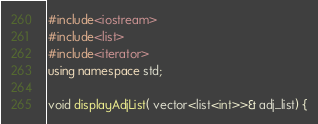Convert code to text. <code><loc_0><loc_0><loc_500><loc_500><_C++_>#include<iostream>
#include<list>
#include<iterator>
using namespace std;

void displayAdjList( vector<list<int>>& adj_list) {</code> 